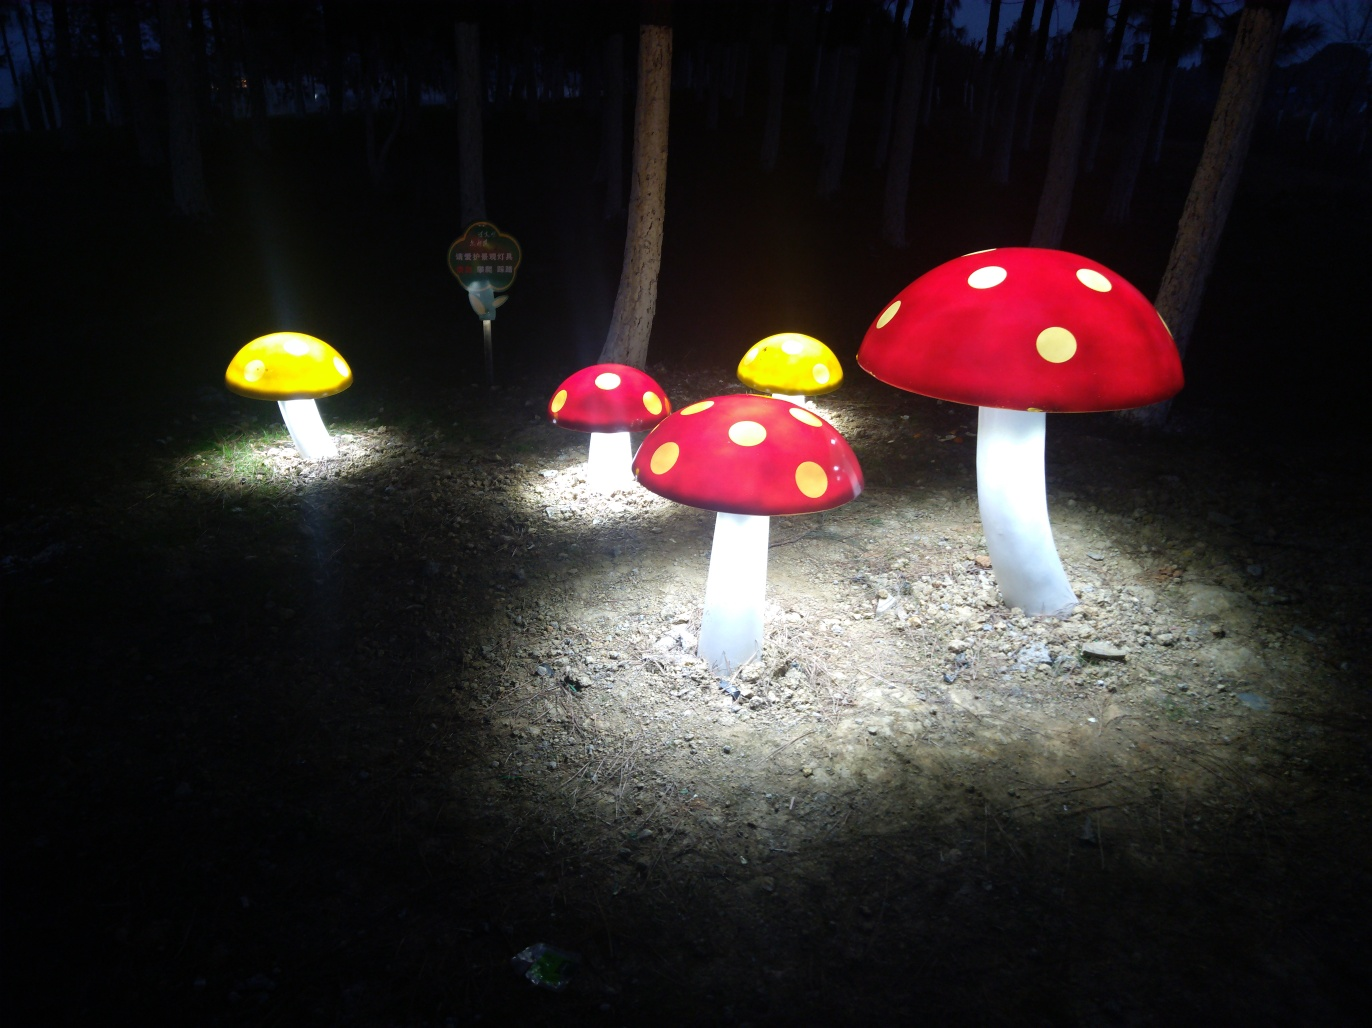Could this be part of an event or festival? The illuminated mushroom figures suggest that this could indeed be part of a thematic event or exhibition, possibly a nighttime garden or forest festival that celebrates fantasy or nature with light installations. 